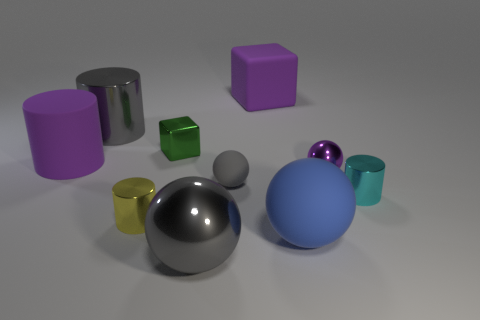If we were to arrange the objects by size, starting with the largest, which order would they appear in? Starting with the largest, the order would be: the large blue sphere, the purple cylinder, the darkish gray sphere, the light gray sphere, the silver cylinder, the silver cylinder with a smaller radius, the green cube, the golden-yellow sphere, and lastly the small cyan cylinder. 